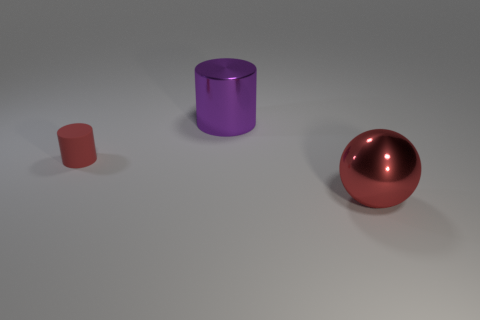Add 2 tiny red rubber things. How many objects exist? 5 Subtract all red cylinders. How many cylinders are left? 1 Subtract all cylinders. How many objects are left? 1 Subtract all purple blocks. How many blue spheres are left? 0 Subtract all metal spheres. Subtract all metal spheres. How many objects are left? 1 Add 1 large spheres. How many large spheres are left? 2 Add 3 big purple cylinders. How many big purple cylinders exist? 4 Subtract 0 brown balls. How many objects are left? 3 Subtract 1 spheres. How many spheres are left? 0 Subtract all purple cylinders. Subtract all cyan cubes. How many cylinders are left? 1 